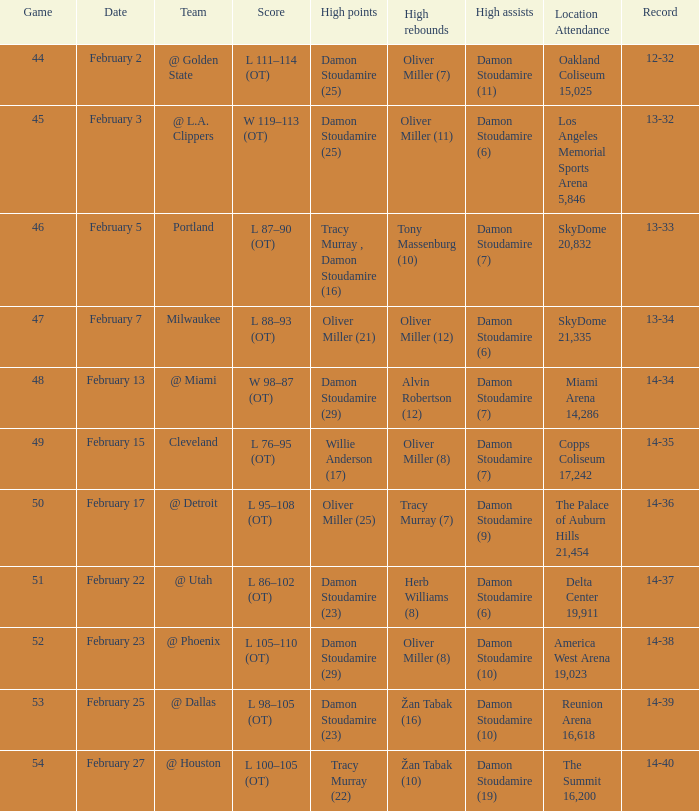How many sites possess a 14-38 record? 1.0. 